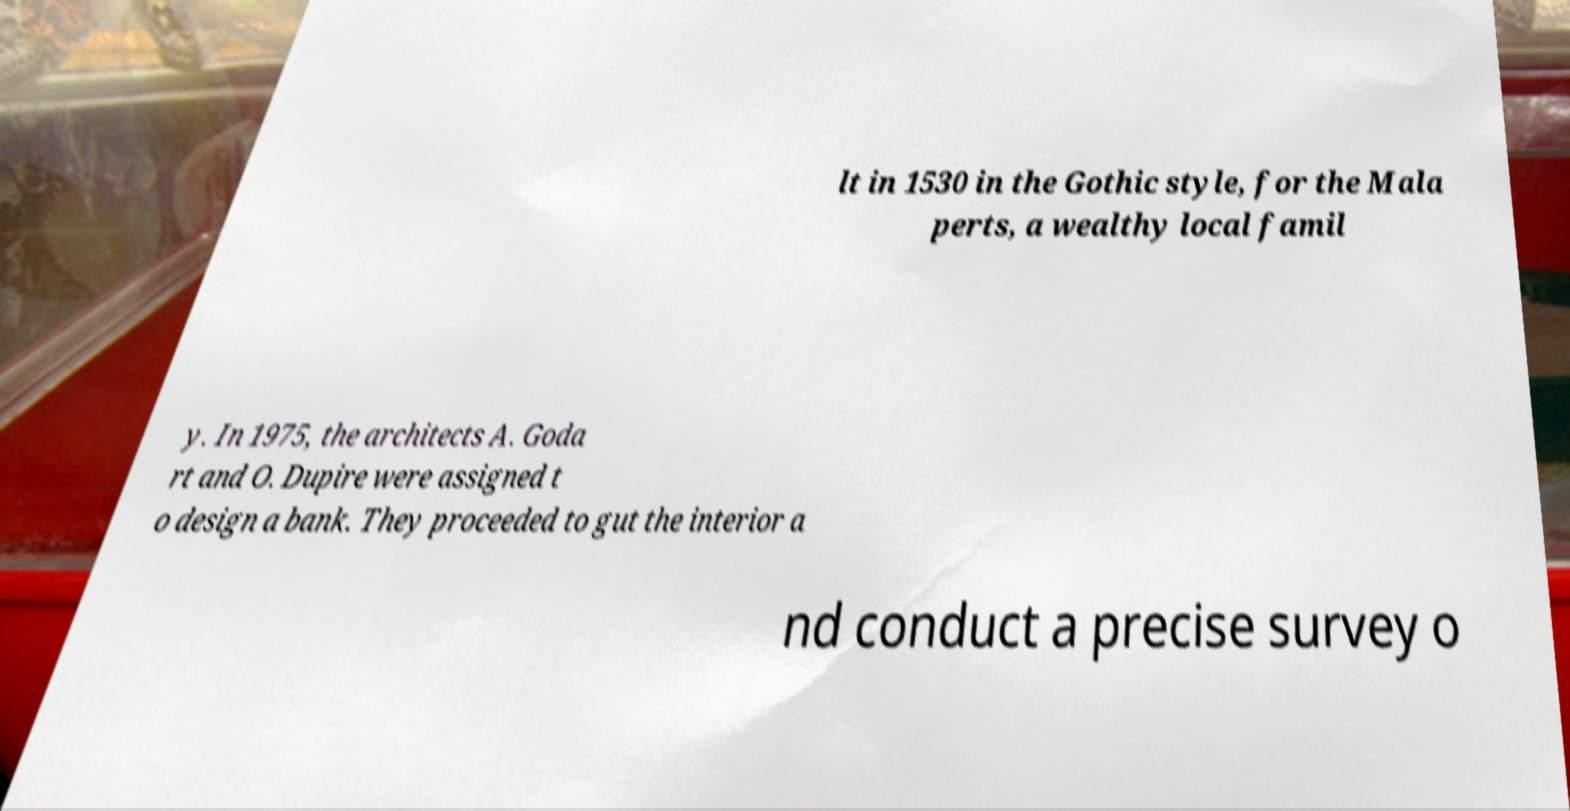What messages or text are displayed in this image? I need them in a readable, typed format. lt in 1530 in the Gothic style, for the Mala perts, a wealthy local famil y. In 1975, the architects A. Goda rt and O. Dupire were assigned t o design a bank. They proceeded to gut the interior a nd conduct a precise survey o 